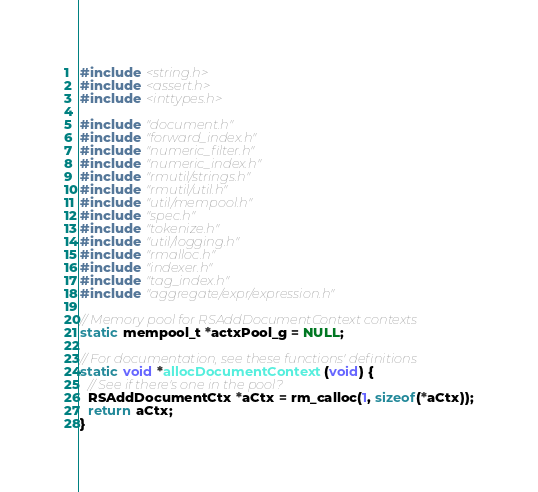Convert code to text. <code><loc_0><loc_0><loc_500><loc_500><_C_>#include <string.h>
#include <assert.h>
#include <inttypes.h>

#include "document.h"
#include "forward_index.h"
#include "numeric_filter.h"
#include "numeric_index.h"
#include "rmutil/strings.h"
#include "rmutil/util.h"
#include "util/mempool.h"
#include "spec.h"
#include "tokenize.h"
#include "util/logging.h"
#include "rmalloc.h"
#include "indexer.h"
#include "tag_index.h"
#include "aggregate/expr/expression.h"

// Memory pool for RSAddDocumentContext contexts
static mempool_t *actxPool_g = NULL;

// For documentation, see these functions' definitions
static void *allocDocumentContext(void) {
  // See if there's one in the pool?
  RSAddDocumentCtx *aCtx = rm_calloc(1, sizeof(*aCtx));
  return aCtx;
}
</code> 